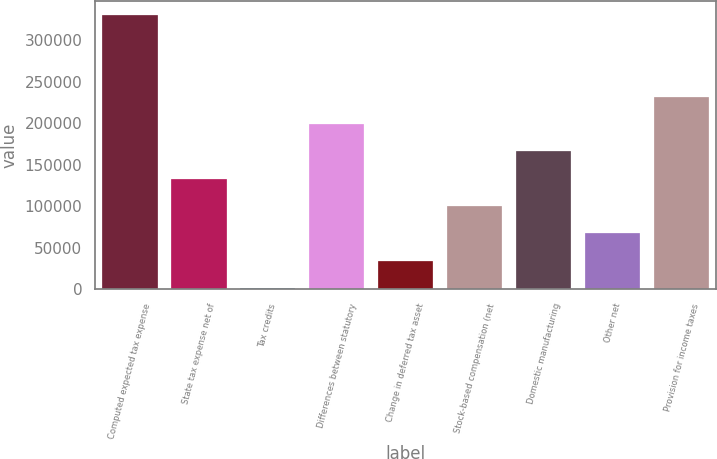Convert chart to OTSL. <chart><loc_0><loc_0><loc_500><loc_500><bar_chart><fcel>Computed expected tax expense<fcel>State tax expense net of<fcel>Tax credits<fcel>Differences between statutory<fcel>Change in deferred tax asset<fcel>Stock-based compensation (net<fcel>Domestic manufacturing<fcel>Other net<fcel>Provision for income taxes<nl><fcel>330103<fcel>132831<fcel>1317<fcel>198589<fcel>34195.6<fcel>99952.8<fcel>165710<fcel>67074.2<fcel>231467<nl></chart> 